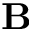Convert formula to latex. <formula><loc_0><loc_0><loc_500><loc_500>B</formula> 